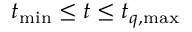<formula> <loc_0><loc_0><loc_500><loc_500>t _ { \min } \leq t \leq t _ { q , \max }</formula> 